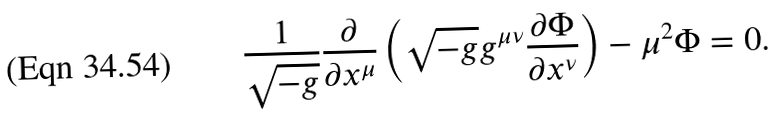<formula> <loc_0><loc_0><loc_500><loc_500>\frac { 1 } { \sqrt { - g } } \frac { \partial } { \partial x ^ { \mu } } \left ( \sqrt { - g } g ^ { \mu \nu } \frac { \partial \Phi } { \partial x ^ { \nu } } \right ) - \mu ^ { 2 } \Phi = 0 .</formula> 